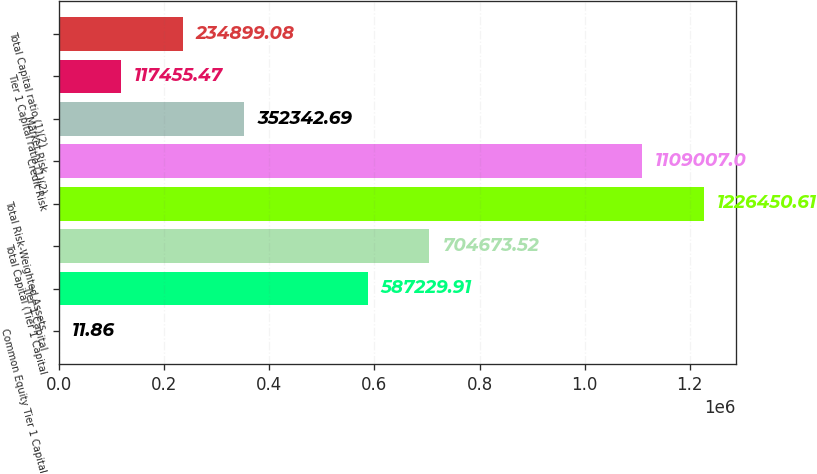Convert chart to OTSL. <chart><loc_0><loc_0><loc_500><loc_500><bar_chart><fcel>Common Equity Tier 1 Capital<fcel>Tier 1 Capital<fcel>Total Capital (Tier 1 Capital<fcel>Total Risk-Weighted Assets<fcel>Credit Risk<fcel>Market Risk<fcel>Tier 1 Capital ratio (1)(2)<fcel>Total Capital ratio (1)(2)<nl><fcel>11.86<fcel>587230<fcel>704674<fcel>1.22645e+06<fcel>1.10901e+06<fcel>352343<fcel>117455<fcel>234899<nl></chart> 